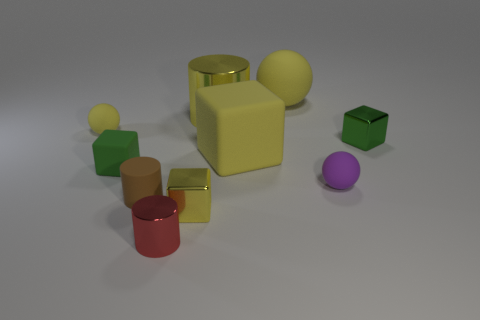Subtract all big rubber spheres. How many spheres are left? 2 Subtract all blue blocks. How many yellow balls are left? 2 Subtract 1 balls. How many balls are left? 2 Subtract all purple spheres. How many spheres are left? 2 Subtract 1 red cylinders. How many objects are left? 9 Subtract all cylinders. How many objects are left? 7 Subtract all brown cylinders. Subtract all gray cubes. How many cylinders are left? 2 Subtract all tiny yellow metal cubes. Subtract all red things. How many objects are left? 8 Add 5 large rubber cubes. How many large rubber cubes are left? 6 Add 10 small brown metallic spheres. How many small brown metallic spheres exist? 10 